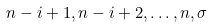Convert formula to latex. <formula><loc_0><loc_0><loc_500><loc_500>n - i + 1 , n - i + 2 , \dots , n , \sigma</formula> 